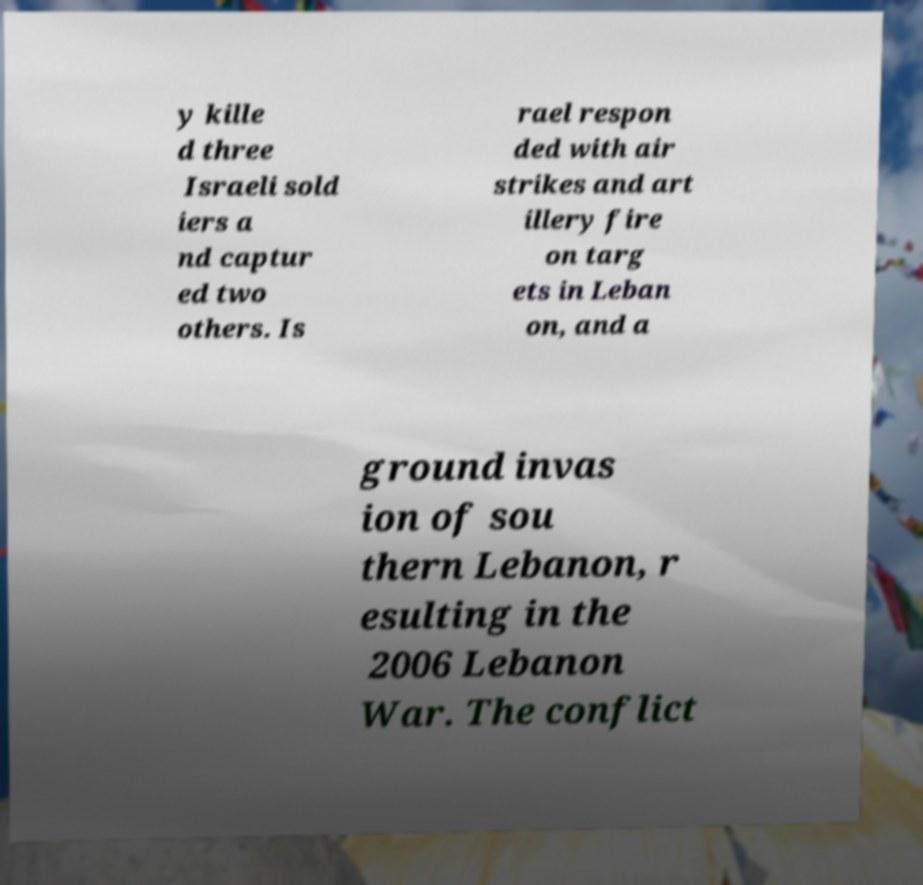For documentation purposes, I need the text within this image transcribed. Could you provide that? y kille d three Israeli sold iers a nd captur ed two others. Is rael respon ded with air strikes and art illery fire on targ ets in Leban on, and a ground invas ion of sou thern Lebanon, r esulting in the 2006 Lebanon War. The conflict 